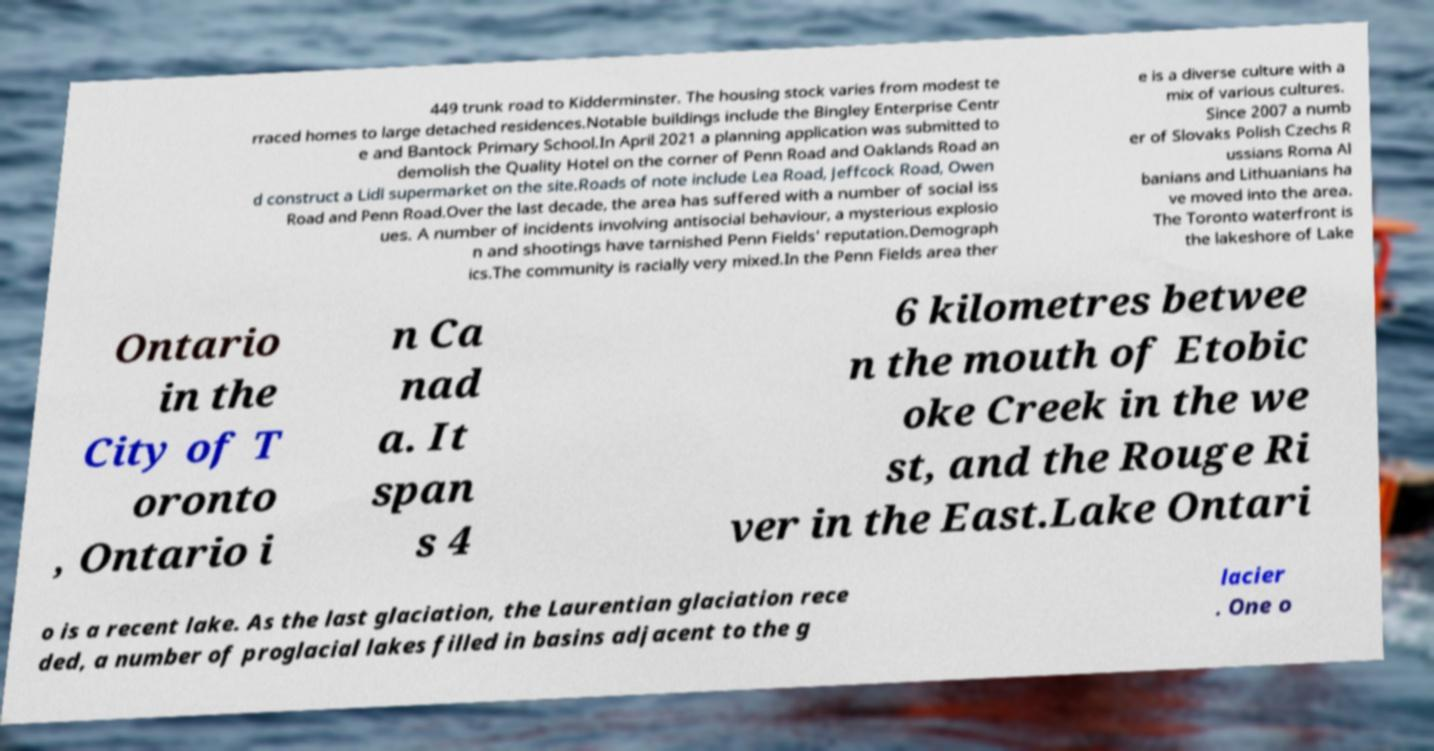Can you accurately transcribe the text from the provided image for me? 449 trunk road to Kidderminster. The housing stock varies from modest te rraced homes to large detached residences.Notable buildings include the Bingley Enterprise Centr e and Bantock Primary School.In April 2021 a planning application was submitted to demolish the Quality Hotel on the corner of Penn Road and Oaklands Road an d construct a Lidl supermarket on the site.Roads of note include Lea Road, Jeffcock Road, Owen Road and Penn Road.Over the last decade, the area has suffered with a number of social iss ues. A number of incidents involving antisocial behaviour, a mysterious explosio n and shootings have tarnished Penn Fields' reputation.Demograph ics.The community is racially very mixed.In the Penn Fields area ther e is a diverse culture with a mix of various cultures. Since 2007 a numb er of Slovaks Polish Czechs R ussians Roma Al banians and Lithuanians ha ve moved into the area. The Toronto waterfront is the lakeshore of Lake Ontario in the City of T oronto , Ontario i n Ca nad a. It span s 4 6 kilometres betwee n the mouth of Etobic oke Creek in the we st, and the Rouge Ri ver in the East.Lake Ontari o is a recent lake. As the last glaciation, the Laurentian glaciation rece ded, a number of proglacial lakes filled in basins adjacent to the g lacier . One o 